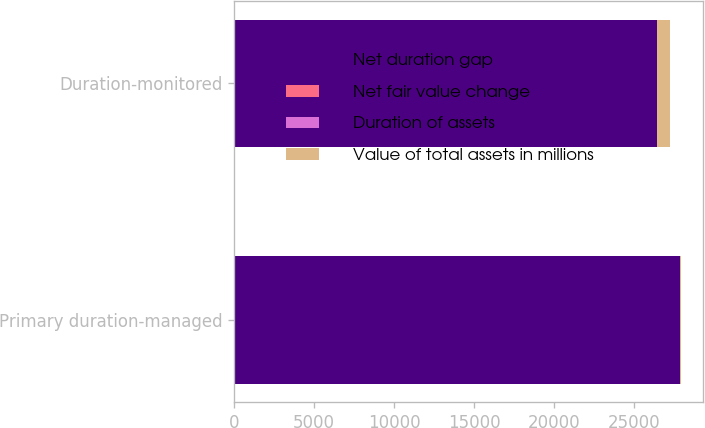<chart> <loc_0><loc_0><loc_500><loc_500><stacked_bar_chart><ecel><fcel>Primary duration-managed<fcel>Duration-monitored<nl><fcel>Net duration gap<fcel>27903<fcel>26446.4<nl><fcel>Net fair value change<fcel>3.86<fcel>4.29<nl><fcel>Duration of assets<fcel>0.13<fcel>3.07<nl><fcel>Value of total assets in millions<fcel>36.3<fcel>811.5<nl></chart> 